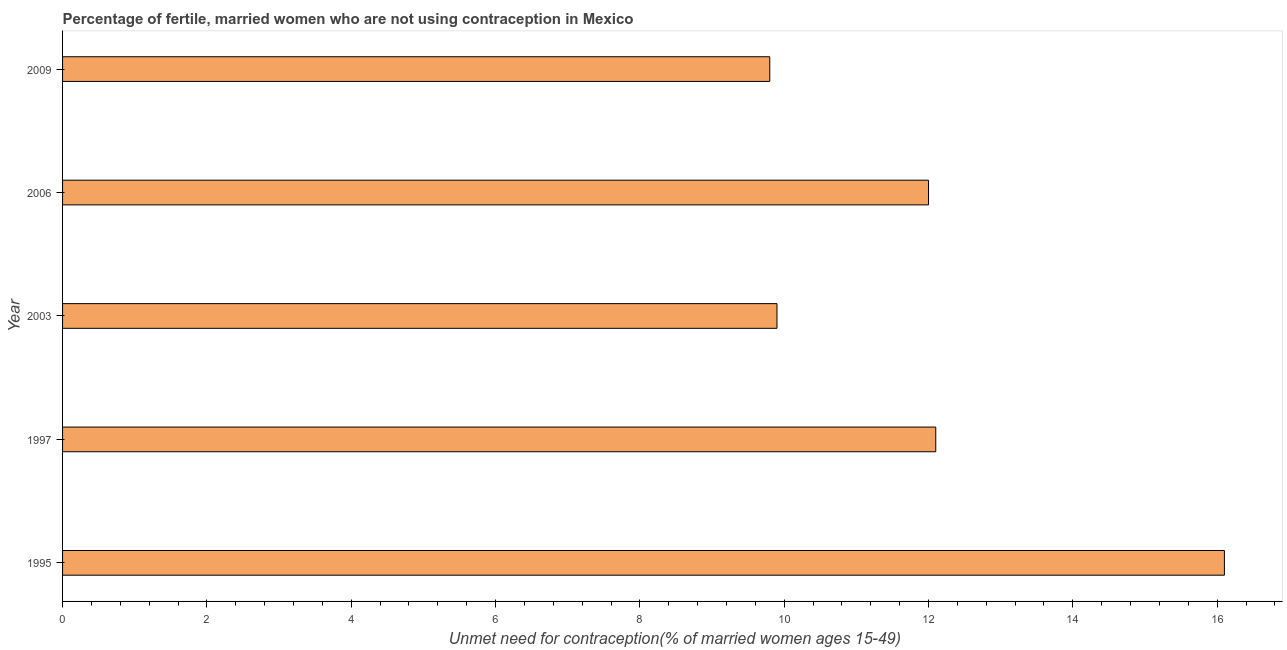Does the graph contain any zero values?
Ensure brevity in your answer.  No. What is the title of the graph?
Offer a very short reply. Percentage of fertile, married women who are not using contraception in Mexico. What is the label or title of the X-axis?
Keep it short and to the point.  Unmet need for contraception(% of married women ages 15-49). Across all years, what is the maximum number of married women who are not using contraception?
Make the answer very short. 16.1. In which year was the number of married women who are not using contraception maximum?
Keep it short and to the point. 1995. In which year was the number of married women who are not using contraception minimum?
Ensure brevity in your answer.  2009. What is the sum of the number of married women who are not using contraception?
Give a very brief answer. 59.9. What is the difference between the number of married women who are not using contraception in 1997 and 2009?
Your response must be concise. 2.3. What is the average number of married women who are not using contraception per year?
Your answer should be compact. 11.98. What is the median number of married women who are not using contraception?
Your response must be concise. 12. Do a majority of the years between 2009 and 1995 (inclusive) have number of married women who are not using contraception greater than 10.4 %?
Keep it short and to the point. Yes. What is the ratio of the number of married women who are not using contraception in 1995 to that in 2003?
Offer a terse response. 1.63. Is the number of married women who are not using contraception in 1997 less than that in 2009?
Offer a very short reply. No. Is the sum of the number of married women who are not using contraception in 1997 and 2006 greater than the maximum number of married women who are not using contraception across all years?
Provide a short and direct response. Yes. Are all the bars in the graph horizontal?
Offer a very short reply. Yes. How many years are there in the graph?
Keep it short and to the point. 5. What is the difference between two consecutive major ticks on the X-axis?
Provide a short and direct response. 2. What is the  Unmet need for contraception(% of married women ages 15-49) of 1997?
Provide a succinct answer. 12.1. What is the  Unmet need for contraception(% of married women ages 15-49) in 2003?
Give a very brief answer. 9.9. What is the difference between the  Unmet need for contraception(% of married women ages 15-49) in 1995 and 1997?
Provide a succinct answer. 4. What is the difference between the  Unmet need for contraception(% of married women ages 15-49) in 1995 and 2006?
Your answer should be very brief. 4.1. What is the difference between the  Unmet need for contraception(% of married women ages 15-49) in 1995 and 2009?
Your response must be concise. 6.3. What is the difference between the  Unmet need for contraception(% of married women ages 15-49) in 1997 and 2006?
Give a very brief answer. 0.1. What is the difference between the  Unmet need for contraception(% of married women ages 15-49) in 2003 and 2006?
Ensure brevity in your answer.  -2.1. What is the difference between the  Unmet need for contraception(% of married women ages 15-49) in 2003 and 2009?
Ensure brevity in your answer.  0.1. What is the ratio of the  Unmet need for contraception(% of married women ages 15-49) in 1995 to that in 1997?
Make the answer very short. 1.33. What is the ratio of the  Unmet need for contraception(% of married women ages 15-49) in 1995 to that in 2003?
Your response must be concise. 1.63. What is the ratio of the  Unmet need for contraception(% of married women ages 15-49) in 1995 to that in 2006?
Your response must be concise. 1.34. What is the ratio of the  Unmet need for contraception(% of married women ages 15-49) in 1995 to that in 2009?
Your answer should be very brief. 1.64. What is the ratio of the  Unmet need for contraception(% of married women ages 15-49) in 1997 to that in 2003?
Offer a very short reply. 1.22. What is the ratio of the  Unmet need for contraception(% of married women ages 15-49) in 1997 to that in 2009?
Ensure brevity in your answer.  1.24. What is the ratio of the  Unmet need for contraception(% of married women ages 15-49) in 2003 to that in 2006?
Offer a very short reply. 0.82. What is the ratio of the  Unmet need for contraception(% of married women ages 15-49) in 2003 to that in 2009?
Provide a succinct answer. 1.01. What is the ratio of the  Unmet need for contraception(% of married women ages 15-49) in 2006 to that in 2009?
Your answer should be very brief. 1.22. 